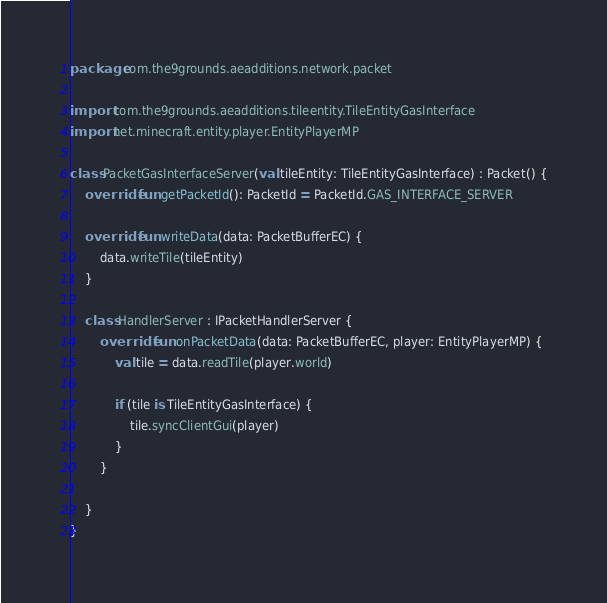Convert code to text. <code><loc_0><loc_0><loc_500><loc_500><_Kotlin_>package com.the9grounds.aeadditions.network.packet

import com.the9grounds.aeadditions.tileentity.TileEntityGasInterface
import net.minecraft.entity.player.EntityPlayerMP

class PacketGasInterfaceServer(val tileEntity: TileEntityGasInterface) : Packet() {
    override fun getPacketId(): PacketId = PacketId.GAS_INTERFACE_SERVER

    override fun writeData(data: PacketBufferEC) {
        data.writeTile(tileEntity)
    }

    class HandlerServer : IPacketHandlerServer {
        override fun onPacketData(data: PacketBufferEC, player: EntityPlayerMP) {
            val tile = data.readTile(player.world)

            if (tile is TileEntityGasInterface) {
                tile.syncClientGui(player)
            }
        }

    }
}</code> 